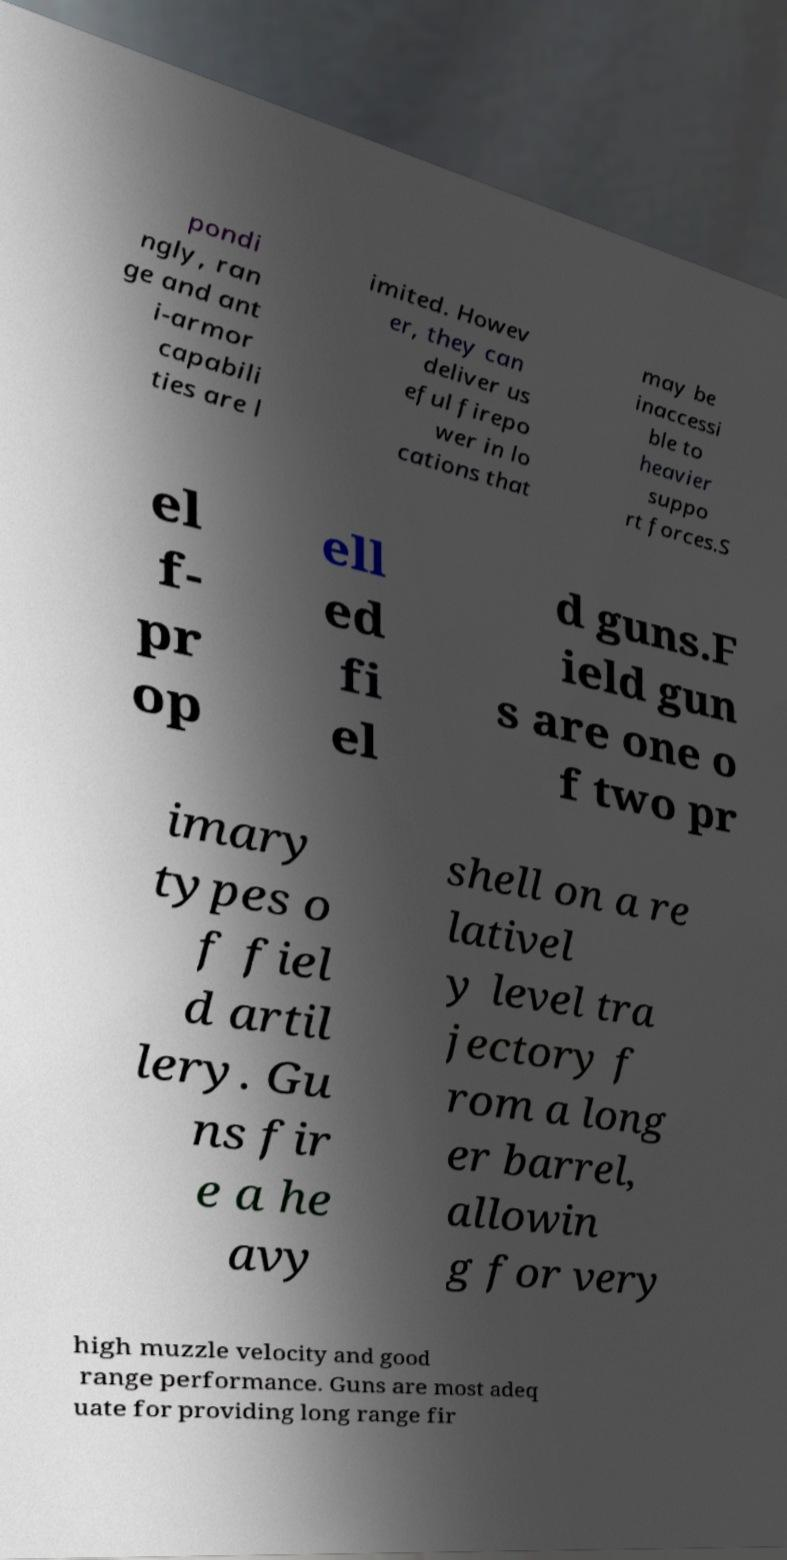There's text embedded in this image that I need extracted. Can you transcribe it verbatim? pondi ngly, ran ge and ant i-armor capabili ties are l imited. Howev er, they can deliver us eful firepo wer in lo cations that may be inaccessi ble to heavier suppo rt forces.S el f- pr op ell ed fi el d guns.F ield gun s are one o f two pr imary types o f fiel d artil lery. Gu ns fir e a he avy shell on a re lativel y level tra jectory f rom a long er barrel, allowin g for very high muzzle velocity and good range performance. Guns are most adeq uate for providing long range fir 